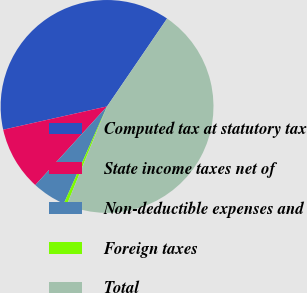Convert chart to OTSL. <chart><loc_0><loc_0><loc_500><loc_500><pie_chart><fcel>Computed tax at statutory tax<fcel>State income taxes net of<fcel>Non-deductible expenses and<fcel>Foreign taxes<fcel>Total<nl><fcel>38.05%<fcel>9.72%<fcel>5.11%<fcel>0.49%<fcel>46.64%<nl></chart> 